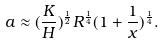Convert formula to latex. <formula><loc_0><loc_0><loc_500><loc_500>a \approx ( \frac { K } { H } ) ^ { \frac { 1 } { 2 } } R ^ { \frac { 1 } { 4 } } ( 1 + \frac { 1 } { x } ) ^ { \frac { 1 } { 4 } } .</formula> 